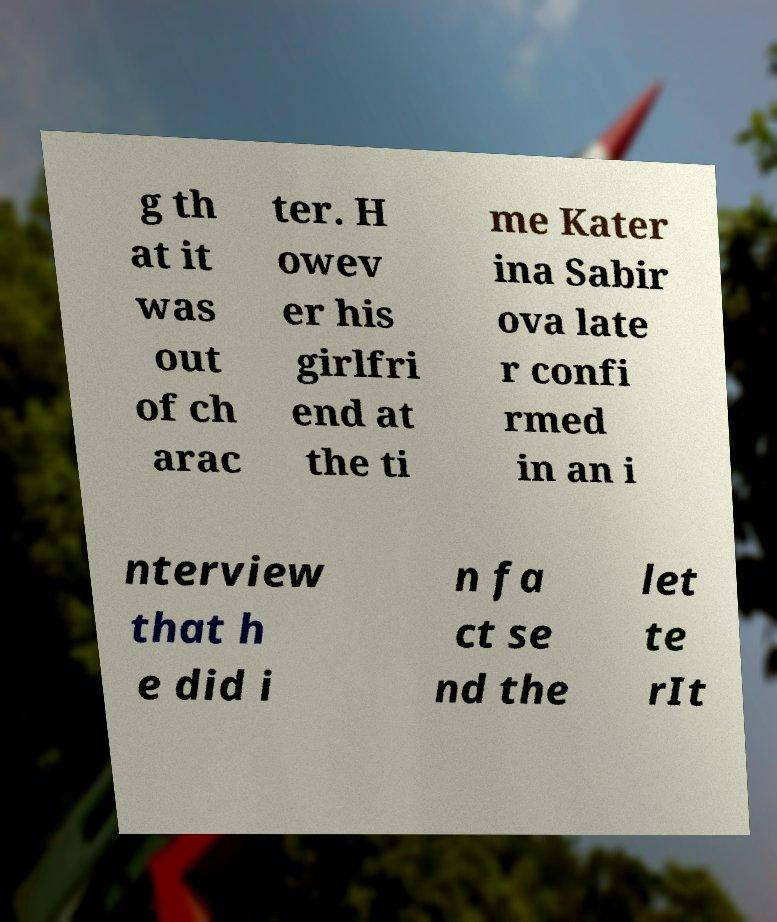I need the written content from this picture converted into text. Can you do that? g th at it was out of ch arac ter. H owev er his girlfri end at the ti me Kater ina Sabir ova late r confi rmed in an i nterview that h e did i n fa ct se nd the let te rIt 